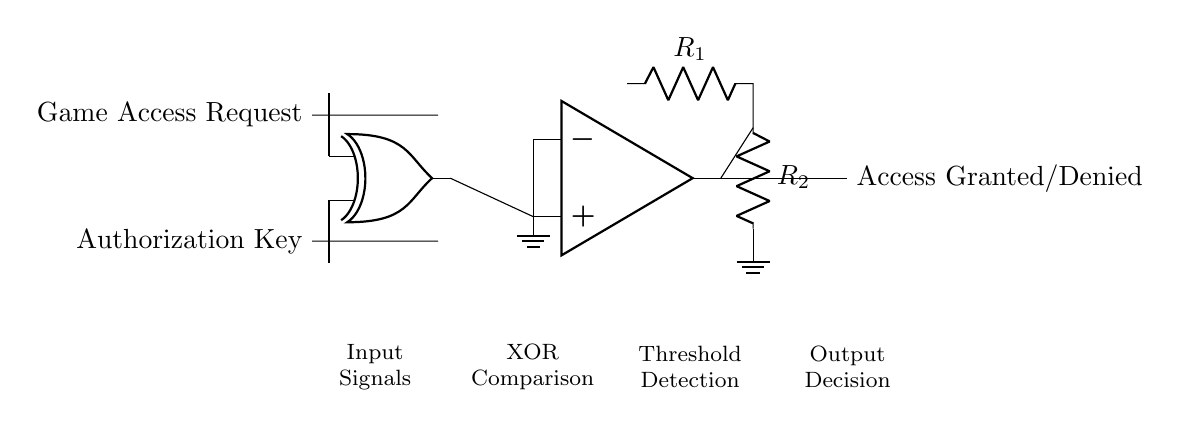What are the input signals of the circuit? The input signals are "Game Access Request" and "Authorization Key". These are the two signals that the comparator circuit uses to evaluate access attempts.
Answer: Game Access Request, Authorization Key What type of logic gate is utilized in this circuit? The circuit uses an XOR gate, indicated by the symbolic representation with two inputs and one output. This gate compares the input signals to produce a unique output based on their values.
Answer: XOR What is the function of the op-amp in this circuit? The op-amp acts as a comparator in this configuration. It compares the output from the XOR gate to a defined threshold set by resistors, determining whether access is granted or denied based on the comparison result.
Answer: Comparator Which component determines the threshold for access detection? The resistors R1 and R2 determine the threshold for access detection by creating a reference voltage for the op-amp to compare its inputs against.
Answer: R1, R2 What would happen if both input signals are high? If both input signals are high, the XOR gate will output low, as an XOR gate only outputs high when one input is true and the other is false. The op-amp will then recognize this low output in comparison to its threshold and deny access.
Answer: Access Denied How does the output signal indicate access status? The output signal from the op-amp is either high or low, corresponding to "Access Granted" when conditions are met (inverted logic from the XOR output) or "Access Denied" otherwise. The final output is based on the comparison logic implemented in the circuit.
Answer: Access Granted/Denied 